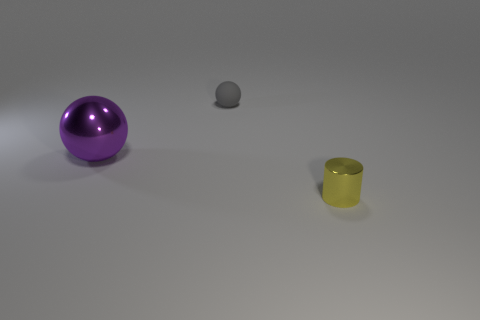Add 2 blue objects. How many objects exist? 5 Subtract all spheres. How many objects are left? 1 Subtract 0 blue cylinders. How many objects are left? 3 Subtract all green rubber cylinders. Subtract all metallic cylinders. How many objects are left? 2 Add 3 small gray objects. How many small gray objects are left? 4 Add 2 tiny yellow objects. How many tiny yellow objects exist? 3 